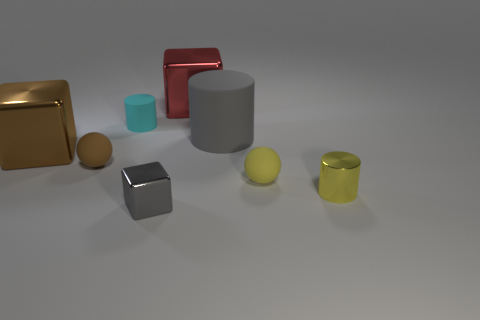Subtract all big blocks. How many blocks are left? 1 Add 1 matte cylinders. How many objects exist? 9 Subtract 1 cylinders. How many cylinders are left? 2 Subtract all yellow cylinders. How many cylinders are left? 2 Subtract all spheres. How many objects are left? 6 Subtract all red cylinders. How many brown balls are left? 1 Subtract all small gray shiny objects. Subtract all small metallic objects. How many objects are left? 5 Add 5 tiny yellow rubber things. How many tiny yellow rubber things are left? 6 Add 6 big red metal cubes. How many big red metal cubes exist? 7 Subtract 0 green balls. How many objects are left? 8 